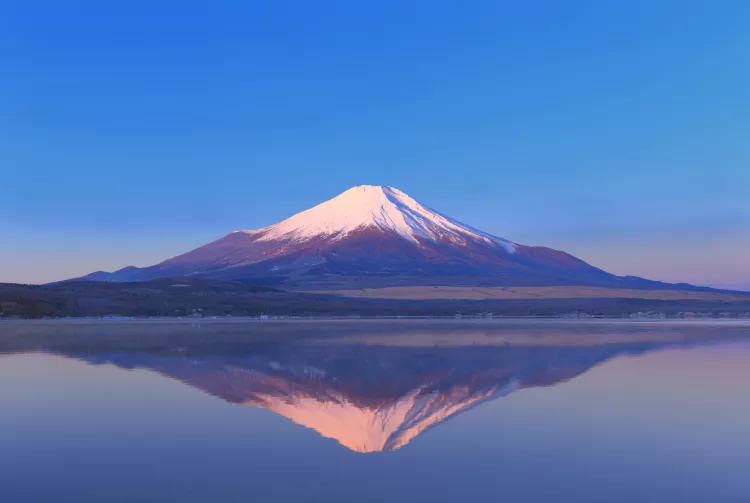What are the key elements in this picture?
 The image captures the majestic Mount Fuji, a renowned landmark in Japan. The mountain, blanketed in snow, stands tall in the center of the frame, its peak tinged with a soft pink hue from the rising sun. The sky above is a gentle light blue, providing a serene backdrop for the mountain. Below, the calm waters mirror the image of Mount Fuji, creating a beautiful reflection that adds depth to the scene. The photograph is taken from a low angle, which amplifies the grandeur of the mountain, making it appear even more imposing and awe-inspiring. 